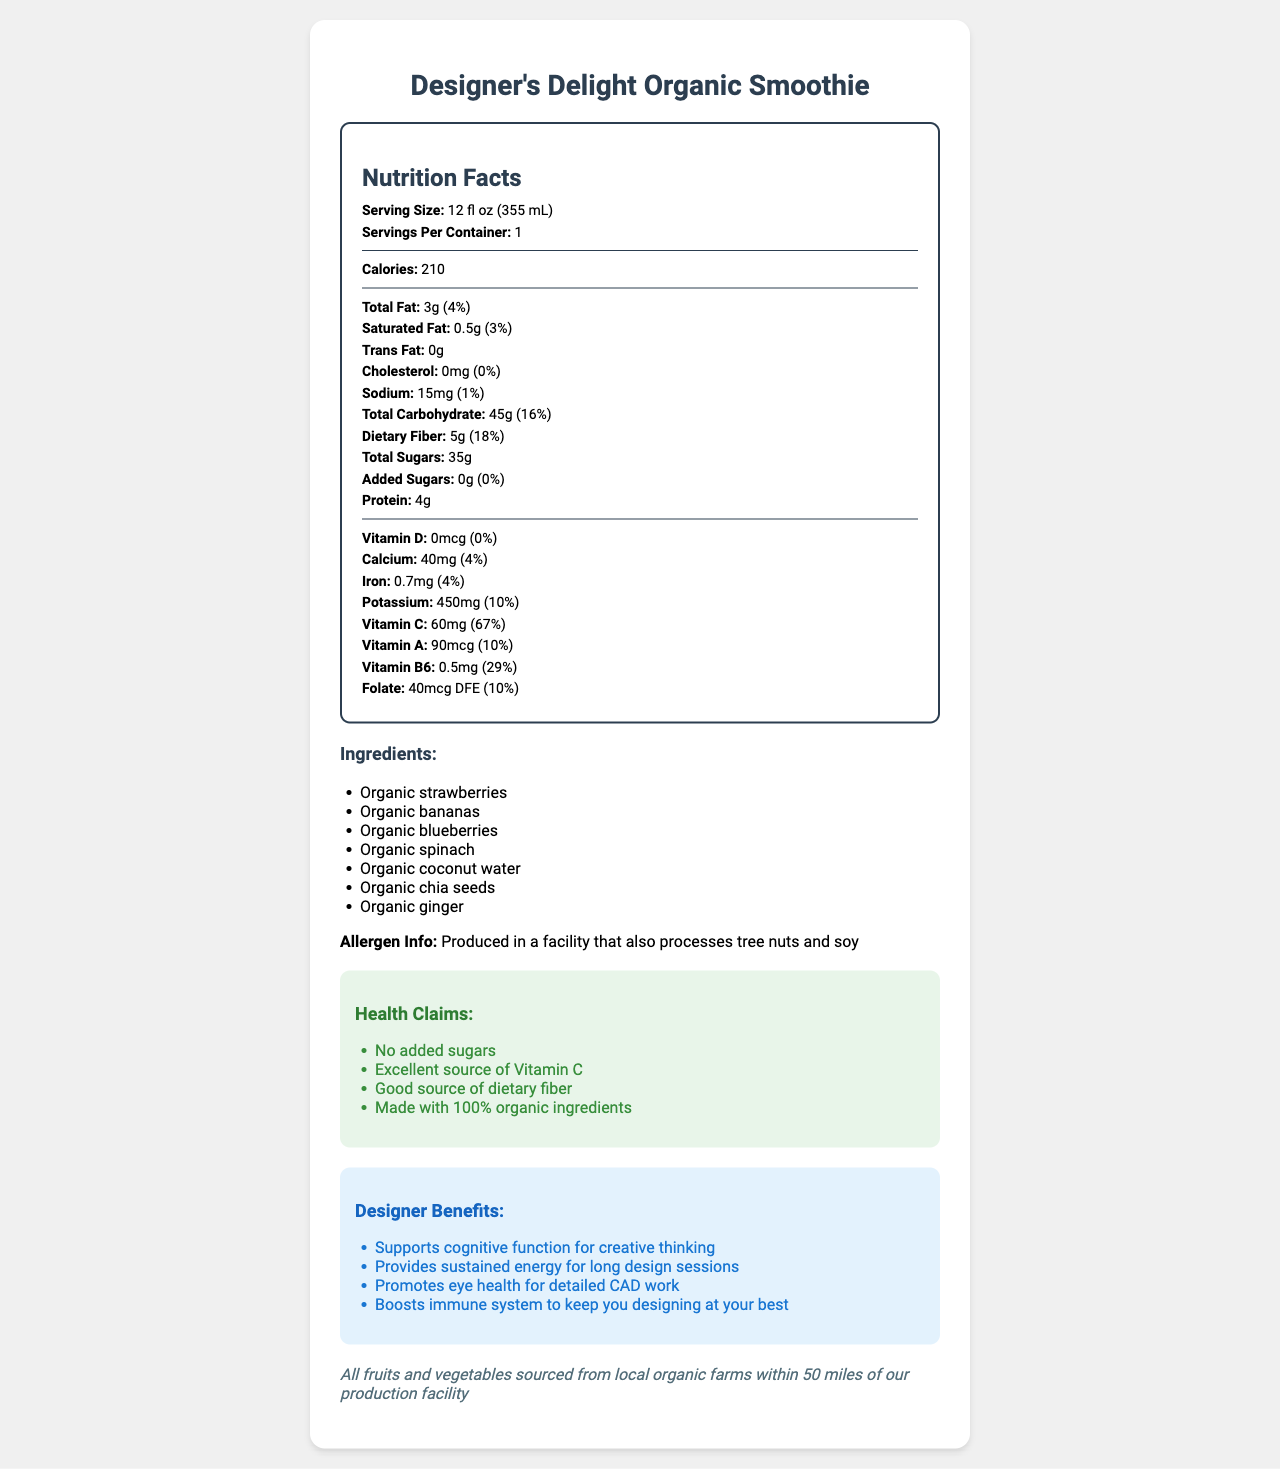what is the serving size of the "Designer's Delight Organic Smoothie"? The serving size is listed at the top of the Nutrition Facts section.
Answer: 12 fl oz (355 mL) how many calories does one serving contain? The calorie count is clearly stated in the nutrition facts.
Answer: 210 calories what percentage of the daily value for dietary fiber does the smoothie provide? The daily value percentage for dietary fiber is listed next to the amount.
Answer: 18% which vitamin has the highest daily value percentage in this smoothie? Vitamin C has a daily value percentage of 67%, which is higher than any other listed vitamin or mineral.
Answer: Vitamin C name two ingredients in the "Designer's Delight Organic Smoothie". These are part of the list under the Ingredients section.
Answer: Organic strawberries, Organic bananas how much iron is in one serving of the smoothie? The amount of iron per serving is listed in the nutrition facts.
Answer: 0.7mg what is the total carbohydrate content in the smoothie? The total carbohydrate content is specified next to the daily value percentage in the Nutrition Facts.
Answer: 45g select the correct allergen information about the smoothie:
A. Contains nuts
B. Contains soy
C. Produced in a facility that also processes tree nuts and soy
D. Contains dairy The allergen information states that the product is produced in a facility that also processes tree nuts and soy.
Answer: C which of the following health benefits is NOT listed for the "Designer's Delight Organic Smoothie"?
1. Supports cognitive function for creative thinking
2. Improves skin health
3. Provides sustained energy for long design sessions
4. Promotes eye health for detailed CAD work The listed health benefits do not mention improving skin health.
Answer: 2 is this smoothie suitable for those avoiding added sugars? The label claims "No added sugars".
Answer: Yes summarize the main attributes of the "Designer's Delight Organic Smoothie". This summary integrates the key elements from the document including the nutrition facts, ingredients, health claims, and designer-specific benefits.
Answer: The Designer's Delight Organic Smoothie is a locally-sourced, 100% organic fruit smoothie with no added sugars. It contains 210 calories per serving, offers substantial dietary fiber and Vitamin C, and includes ingredients such as organic strawberries, bananas, blueberries, and spinach. It provides designer-specific benefits such as cognitive support and sustained energy, while being produced in a facility that processes tree nuts and soy. what is the cost of the "Designer's Delight Organic Smoothie"? The document does not include any information regarding the price or cost of the smoothie.
Answer: Cannot be determined 